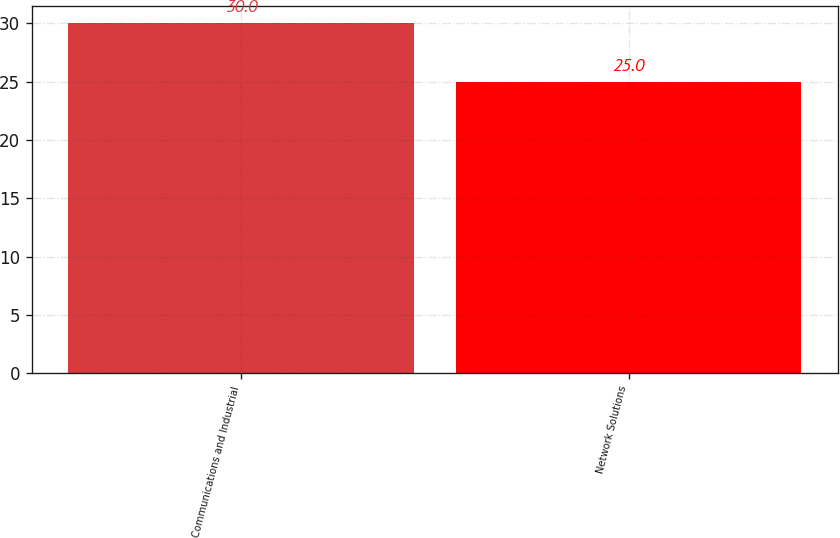<chart> <loc_0><loc_0><loc_500><loc_500><bar_chart><fcel>Communications and Industrial<fcel>Network Solutions<nl><fcel>30<fcel>25<nl></chart> 